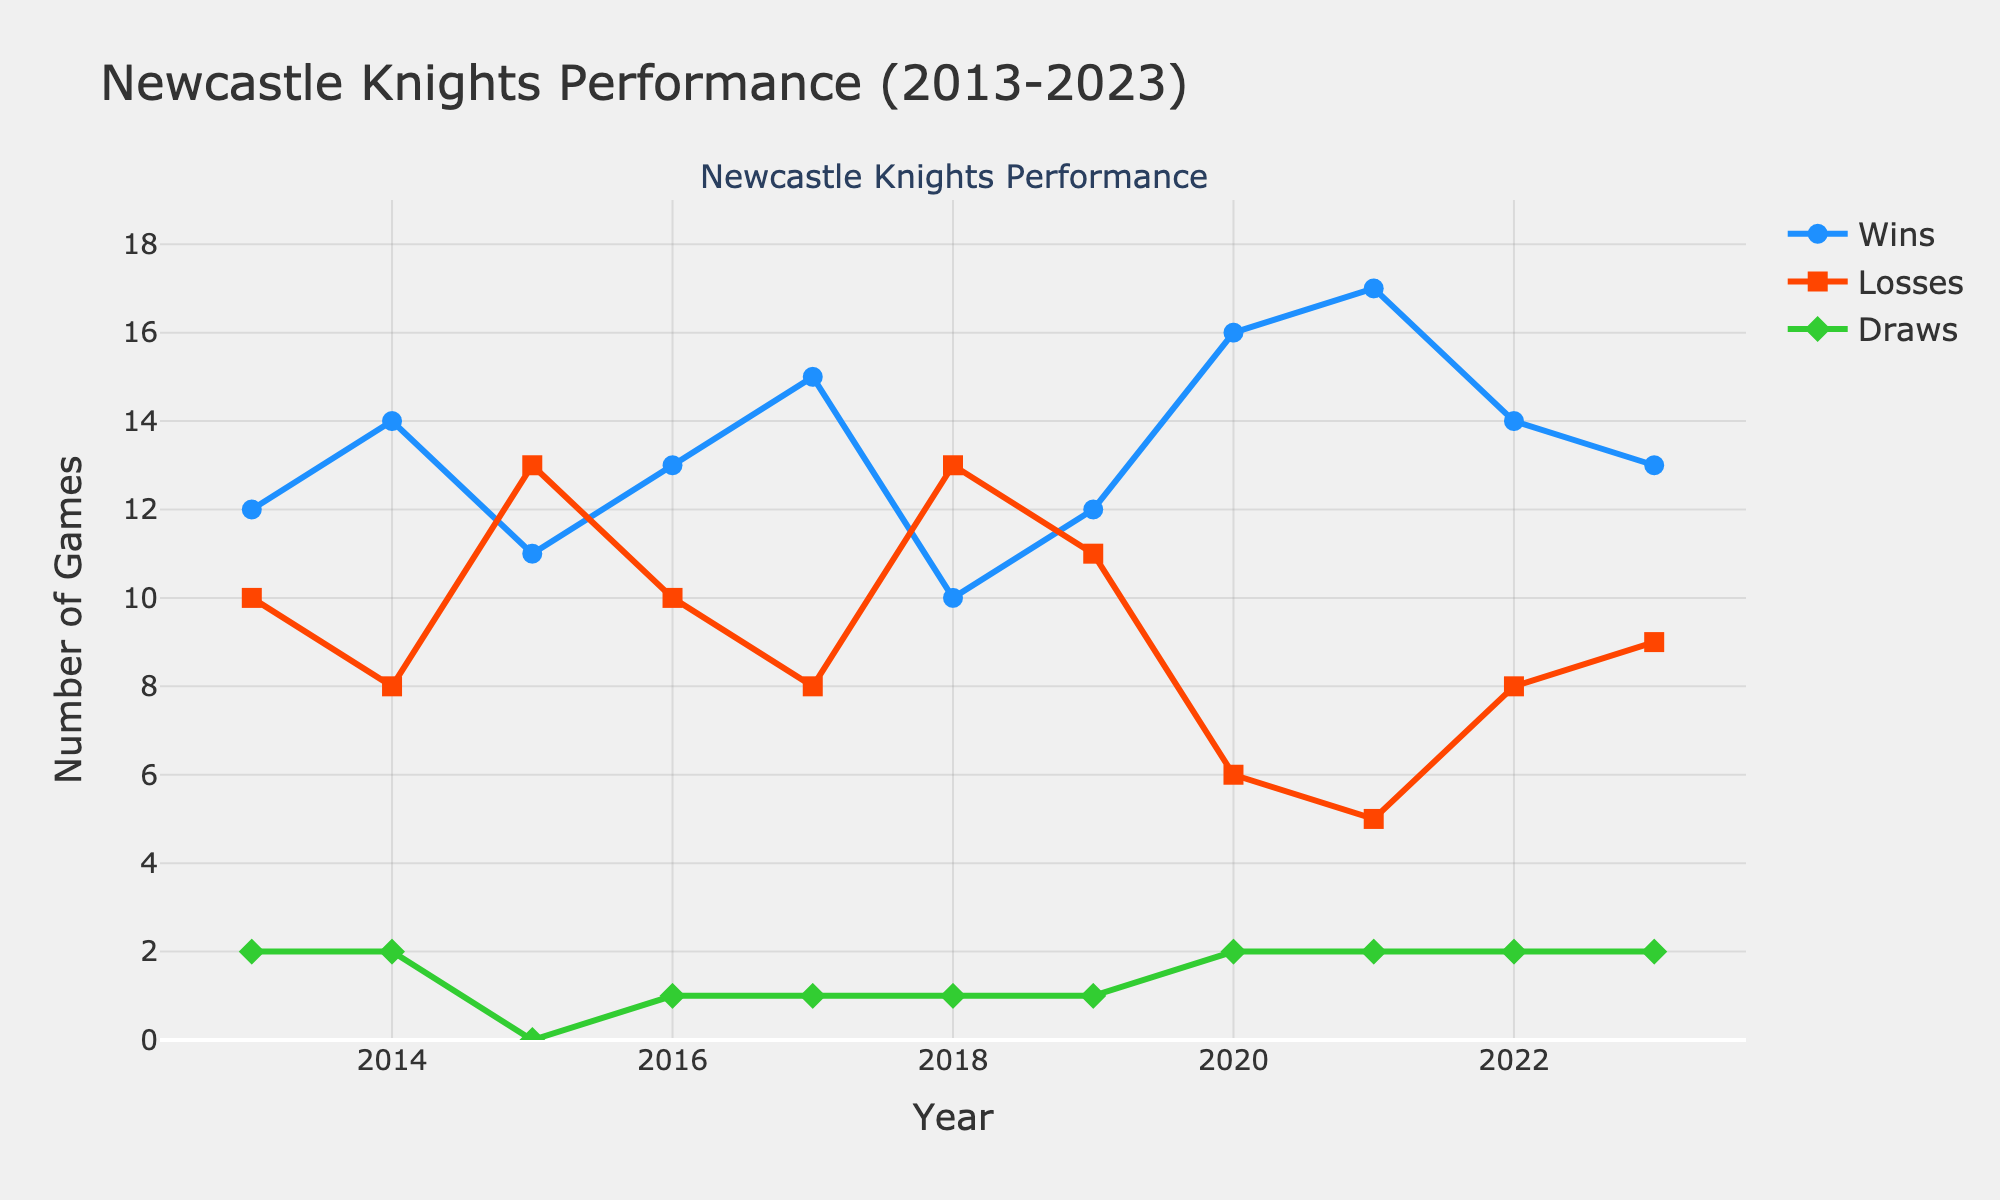What's the title of the figure? The title can be found at the top of the figure.
Answer: Newcastle Knights Performance (2013-2023) What are the axes labels in the figure? The axes labels are located along the x-axis and y-axis.
Answer: Year (x-axis) and Number of Games (y-axis) Which year had the highest number of wins? Look at the line and markers for "Wins" and identify the peak point along the y-axis.
Answer: 2021 Compare the wins in 2016 to the wins in 2018. Which year had more wins? Trace the "Wins" line and observe the y-axis values for the years 2016 and 2018.
Answer: 2016 What is the average number of losses across all years? Add the number of losses for each year and divide by the number of years (11). (10+8+13+10+8+13+11+6+5+8+9) / 11 = 101 / 11 = 9.18
Answer: 9.18 In which year did the team have the lowest number of losses? Identify the lowest point on the "Losses" line and note the corresponding year on the x-axis.
Answer: 2021 How many more wins were there in 2020 compared to 2018? Subtract the number of wins in 2018 from the wins in 2020. 16 - 10 = 6
Answer: 6 Identify two consecutive years with an increase in draws. Find where the "Draws" line goes up consecutively and check the corresponding years on the x-axis.
Answer: 2019-2020 and 2021-2022 In what year did the team have exactly 2 draws? Check the "Draws" line for the value of 2 and note the corresponding year(s).
Answer: 2013, 2014, 2020, 2021, 2022, 2023 Analyze the trend in wins from 2019 to 2021. Did the number of wins increase, decrease, or remain stable? Trace the "Wins" line from 2019 to 2021 and observe the direction.
Answer: Increase 